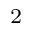<formula> <loc_0><loc_0><loc_500><loc_500>^ { 2 }</formula> 